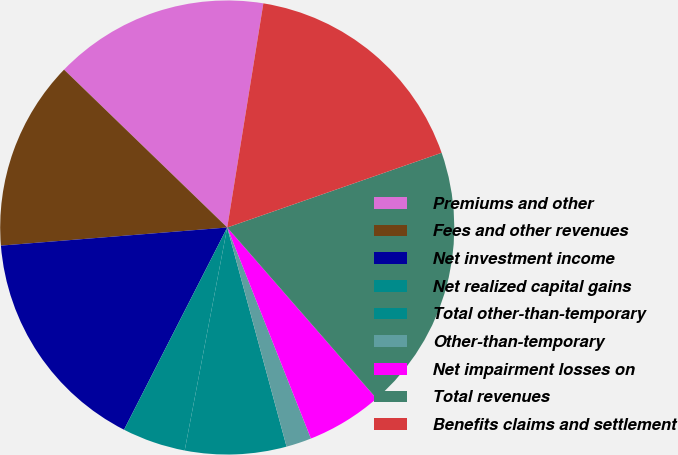Convert chart. <chart><loc_0><loc_0><loc_500><loc_500><pie_chart><fcel>Premiums and other<fcel>Fees and other revenues<fcel>Net investment income<fcel>Net realized capital gains<fcel>Total other-than-temporary<fcel>Other-than-temporary<fcel>Net impairment losses on<fcel>Total revenues<fcel>Benefits claims and settlement<nl><fcel>15.31%<fcel>13.51%<fcel>16.22%<fcel>4.51%<fcel>7.21%<fcel>1.8%<fcel>5.41%<fcel>18.92%<fcel>17.12%<nl></chart> 